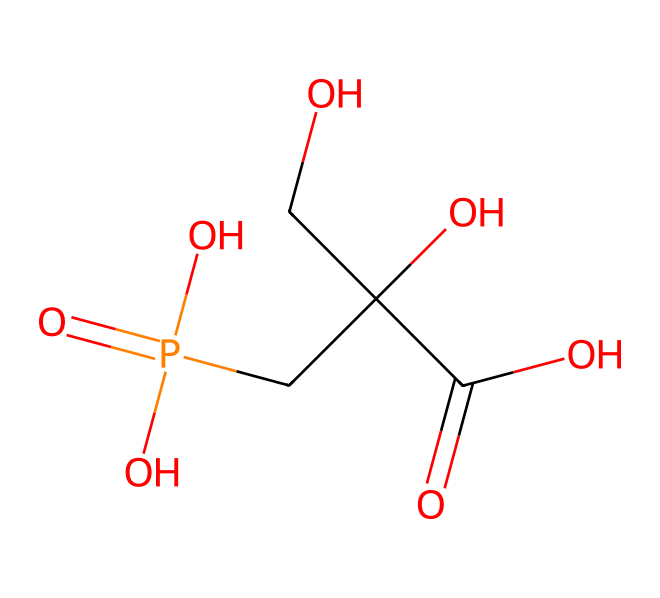What is the chemical name of this herbicide? The structure corresponds to glyphosate, which is commonly used in agriculture as a herbicide. This is identified by recognizing the molecular structure along with its common chemical components.
Answer: glyphosate How many carbon atoms are in this molecule? In the given SMILES representation, there are 3 carbon atoms in the main chain, plus 1 carbon from the carboxylic acid side, making a total of 4 carbon atoms. Count each 'C' in the structure.
Answer: 4 How many oxygen atoms are present in glyphosate? By analyzing the SMILES structure, the number of 'O' characters corresponds to the oxygen atoms. There are a total of 6 oxygen atoms in glyphosate.
Answer: 6 What functional groups are present in glyphosate? The structure shows multiple functional groups, including a phosphate group (P=O), two carboxylic acid groups (-COOH), and a hydroxyl group (-OH). Identify parts of the structure that match these groups.
Answer: phosphate, carboxylic acid, hydroxyl Which part of the molecule contributes to its herbicidal activity? The presence of the phosphonic acid group is crucial for glyphosate's herbicidal activity, as it mimics the amino acid glycine and interferes with specific biochemical pathways in plants. Recognize the specific features of the structure that denote this group.
Answer: phosphonic acid group What is the molecular weight of glyphosate? To calculate molecular weight, sum the atomic weights of each atom represented in the structure: Carbon, Hydrogen, Nitrogen, and Oxygen. By adding these together, the molecular weight is determined.
Answer: 169.07 g/mol How does the chemical structure of glyphosate affect its solubility? Glyphosate's multiple functional groups, particularly the carboxylic acid groups, contribute to its high solubility in water due to their ability to form hydrogen bonds. Assess how the structure promotes solubility through interactions with water.
Answer: high solubility 